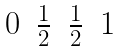Convert formula to latex. <formula><loc_0><loc_0><loc_500><loc_500>\begin{matrix} 0 & \frac { 1 } { 2 } & \frac { 1 } { 2 } & 1 \end{matrix}</formula> 